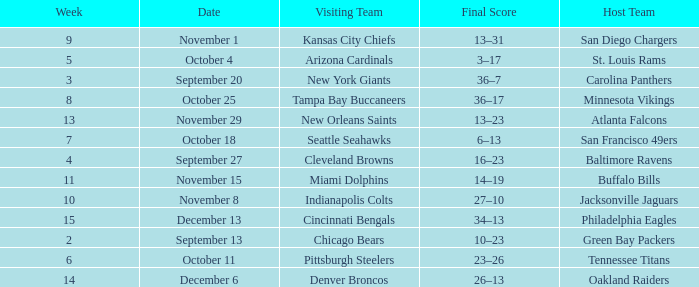What team played on the road against the Buffalo Bills at home ? Miami Dolphins. 